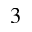<formula> <loc_0><loc_0><loc_500><loc_500>^ { 3 }</formula> 